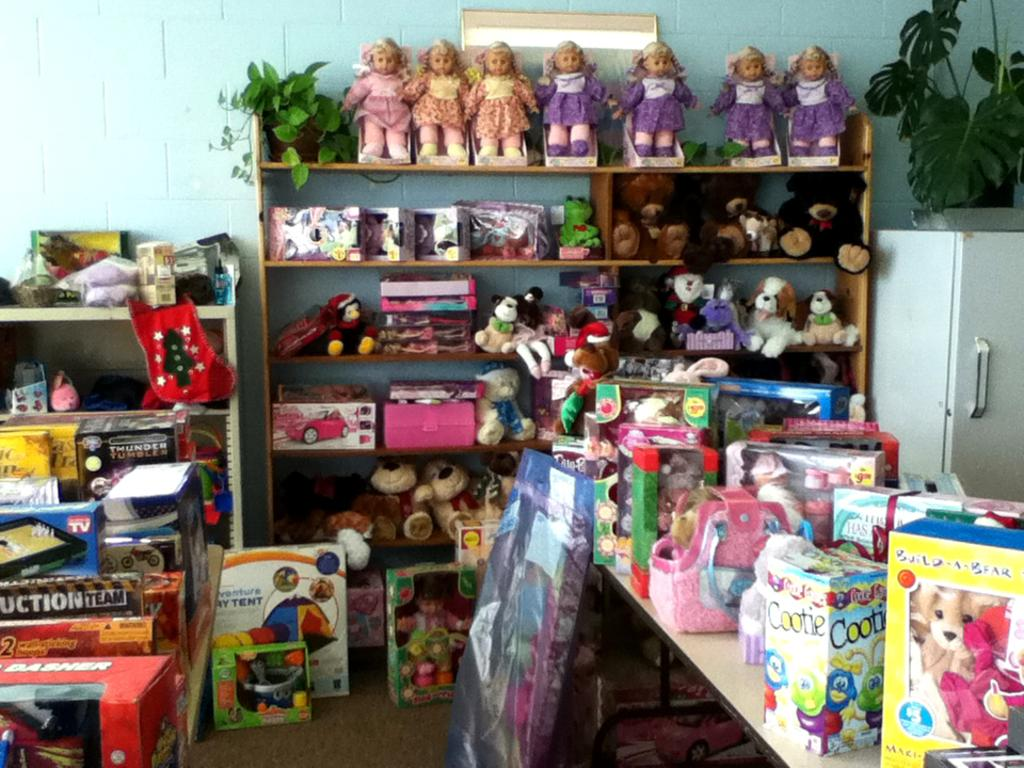<image>
Render a clear and concise summary of the photo. a group of toys, one of which is build a bear 